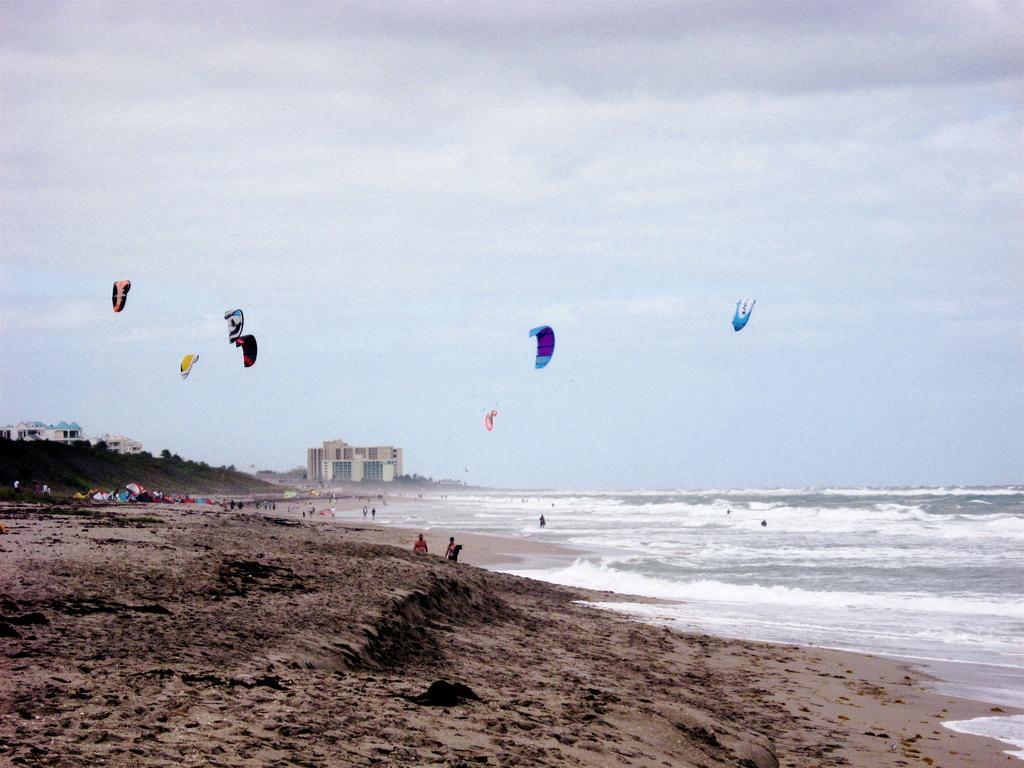How would you summarize this image in a sentence or two? In this image I can see group of people, some are standing and some are walking. Background I can see few multicolor parachutes, trees in green color, few buildings, water and the sky is in white color. 